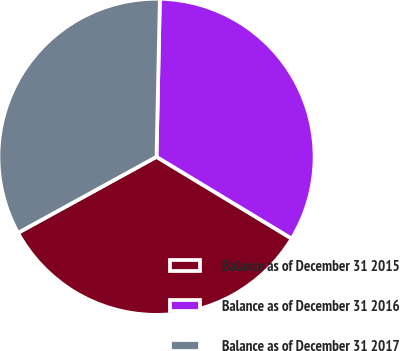<chart> <loc_0><loc_0><loc_500><loc_500><pie_chart><fcel>Balance as of December 31 2015<fcel>Balance as of December 31 2016<fcel>Balance as of December 31 2017<nl><fcel>33.35%<fcel>33.32%<fcel>33.33%<nl></chart> 